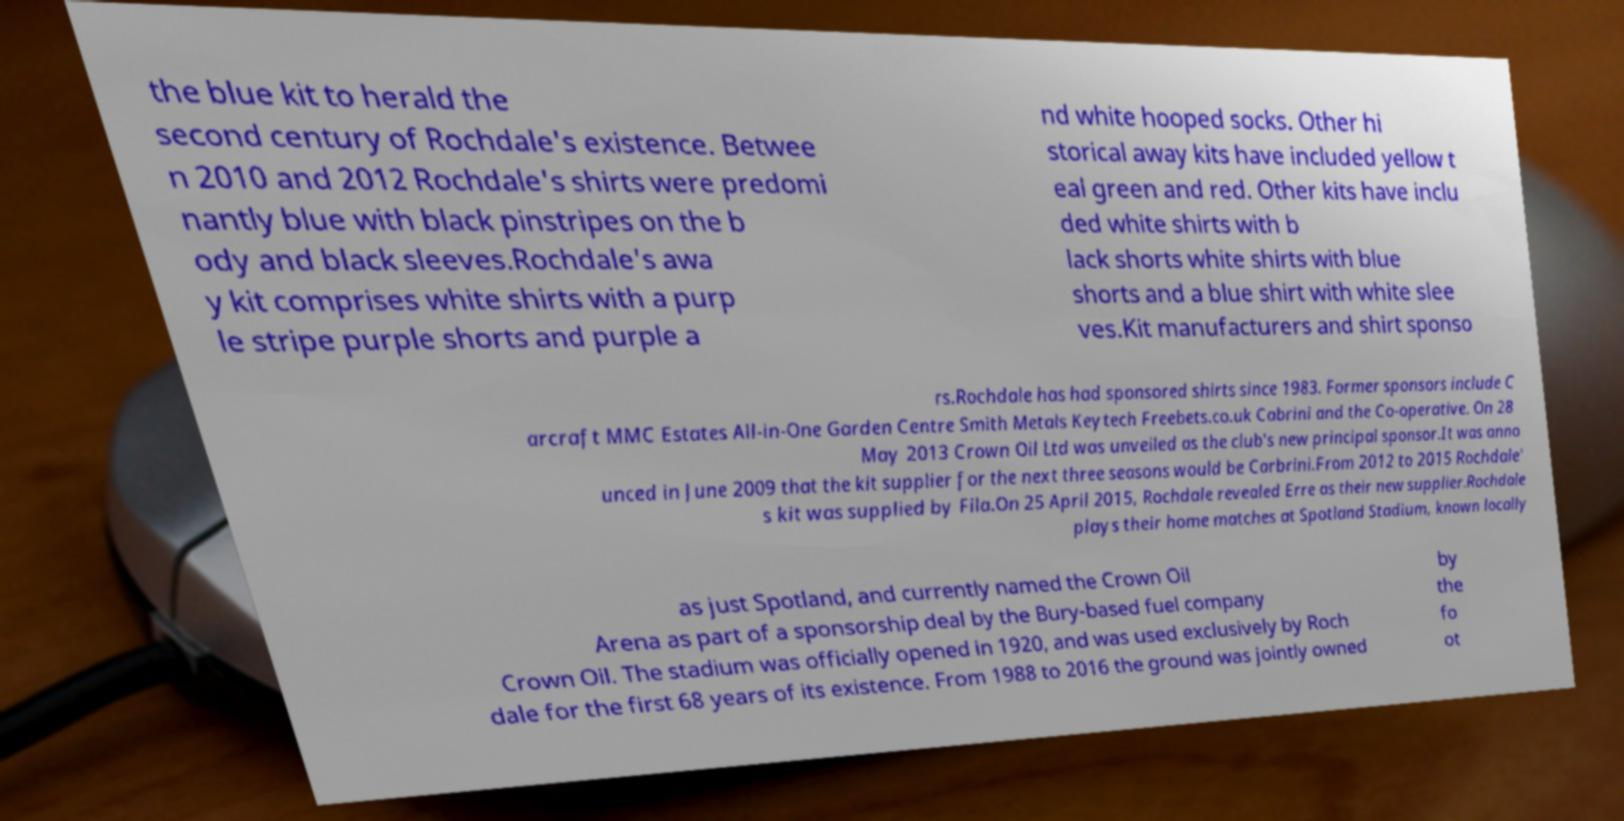Could you assist in decoding the text presented in this image and type it out clearly? the blue kit to herald the second century of Rochdale's existence. Betwee n 2010 and 2012 Rochdale's shirts were predomi nantly blue with black pinstripes on the b ody and black sleeves.Rochdale's awa y kit comprises white shirts with a purp le stripe purple shorts and purple a nd white hooped socks. Other hi storical away kits have included yellow t eal green and red. Other kits have inclu ded white shirts with b lack shorts white shirts with blue shorts and a blue shirt with white slee ves.Kit manufacturers and shirt sponso rs.Rochdale has had sponsored shirts since 1983. Former sponsors include C arcraft MMC Estates All-in-One Garden Centre Smith Metals Keytech Freebets.co.uk Cabrini and the Co-operative. On 28 May 2013 Crown Oil Ltd was unveiled as the club's new principal sponsor.It was anno unced in June 2009 that the kit supplier for the next three seasons would be Carbrini.From 2012 to 2015 Rochdale' s kit was supplied by Fila.On 25 April 2015, Rochdale revealed Erre as their new supplier.Rochdale plays their home matches at Spotland Stadium, known locally as just Spotland, and currently named the Crown Oil Arena as part of a sponsorship deal by the Bury-based fuel company Crown Oil. The stadium was officially opened in 1920, and was used exclusively by Roch dale for the first 68 years of its existence. From 1988 to 2016 the ground was jointly owned by the fo ot 